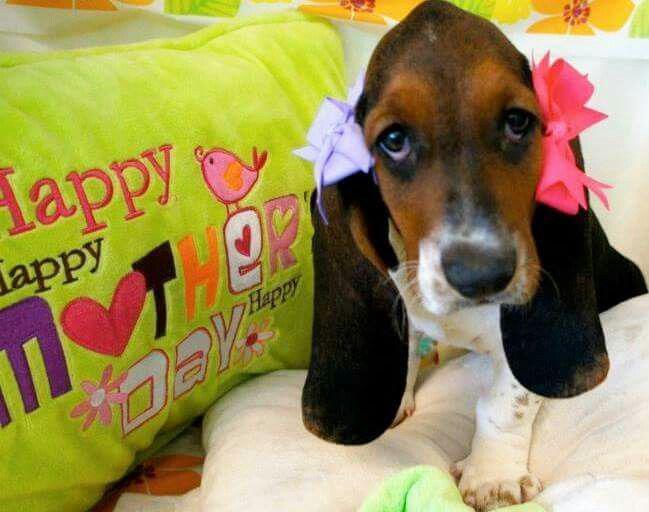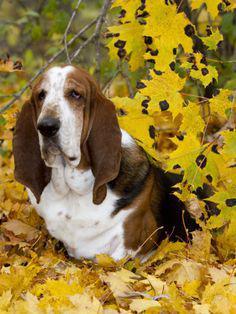The first image is the image on the left, the second image is the image on the right. For the images shown, is this caption "In one of the images, a basset hound is among colorful yellow leaves" true? Answer yes or no. Yes. The first image is the image on the left, the second image is the image on the right. Analyze the images presented: Is the assertion "There are three hounds in the right image." valid? Answer yes or no. No. 